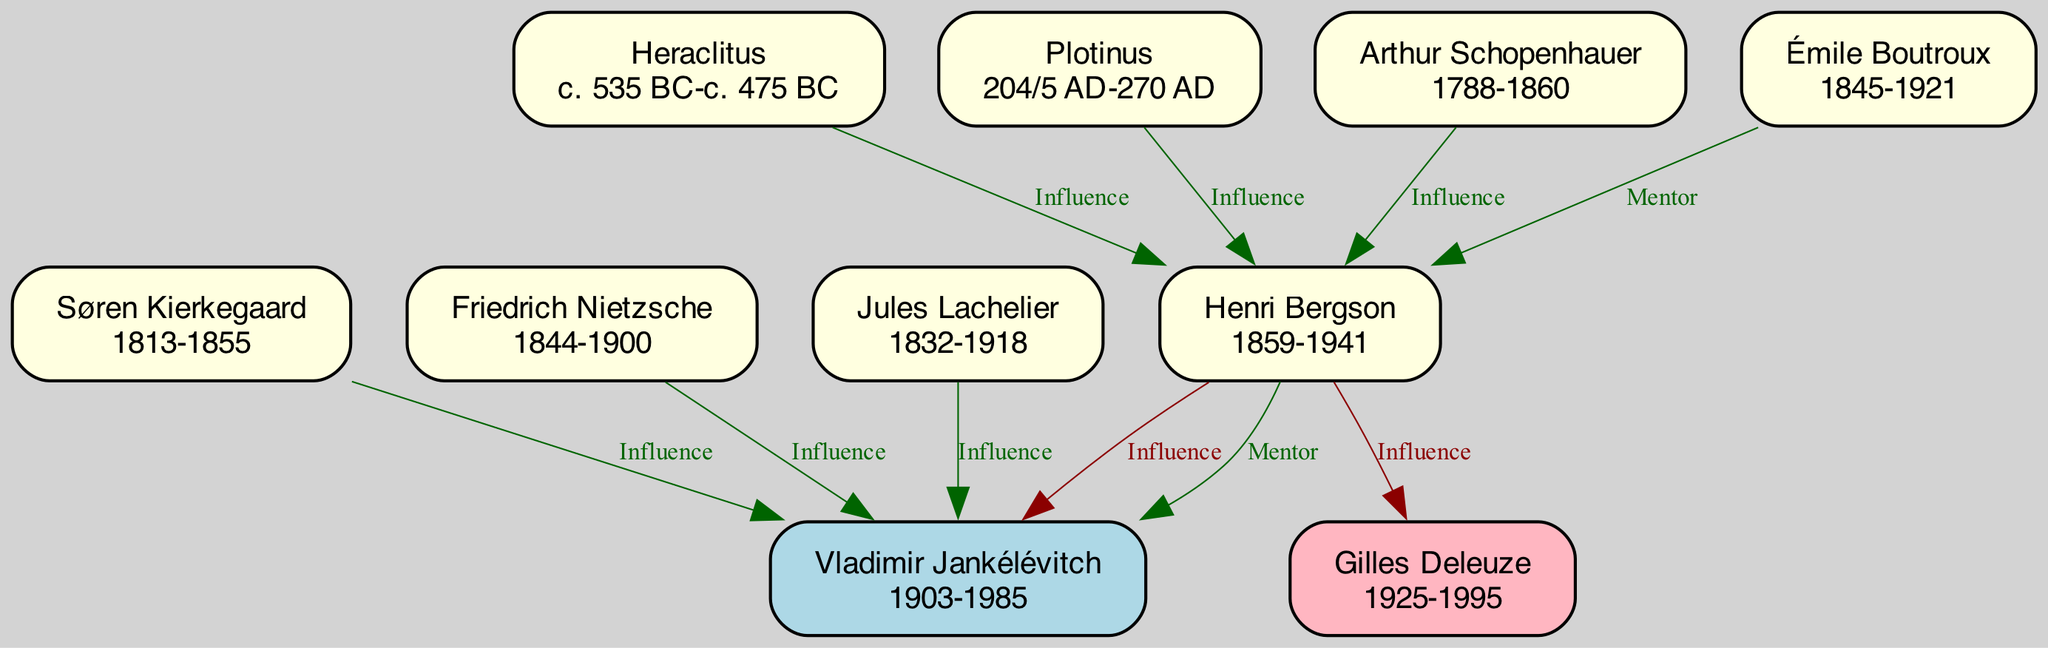What is the relationship between Henri Bergson and Vladimir Jankélévitch? The diagram shows that Henri Bergson is listed as an influence on Vladimir Jankélévitch, indicating a one-way relationship where Bergson directly impacted Jankélévitch's thought.
Answer: Influence How many philosophers influenced Henri Bergson? By counting the nodes connected to Bergson that show the 'influence' relationship, there are four listed influences: Heraclitus, Plotinus, Arthur Schopenhauer, and Émile Boutroux.
Answer: 4 Who was the mentor of Vladimir Jankélévitch? The diagram indicates that Henri Bergson served as a mentor to Vladimir Jankélévitch, highlighting the personal interaction and influence Jankélévitch received from Bergson.
Answer: Henri Bergson What are the birth years of the philosophers listed? The diagram provides birth years for each philosopher listed, such as Henri Bergson (1859), Vladimir Jankélévitch (1903), Heraclitus (c. 535 BC), and others. The focus here can be on any specific philosopher asked about.
Answer: 1859, 1903, c. 535 BC (varies depending on philosopher) Which philosopher influenced both Henri Bergson and Vladimir Jankélévitch? When examining the diagram, it is evident that Henri Bergson is shown to influence Vladimir Jankélévitch, with no other philosopher directly influencing both. Therefore, Bergson uniquely connects these two thinkers.
Answer: Henri Bergson Which philosopher is noted for influence through metaphysical and spiritual dimensions? According to the diagram, Plotinus is specifically mentioned as having an influence on Henri Bergson through metaphysical and spiritual ideas, demonstrating his significance in Bergson's thought.
Answer: Plotinus How many nodes representing philosophers are in the diagram? By counting all the distinct philosophers represented, including those who influenced and were influenced, a total of eight individual philosophers can be identified within the diagram structure.
Answer: 8 Which philosopher is associated with existentialism in relation to Vladimir Jankélévitch? The diagram indicates that Søren Kierkegaard, who had a significant focus on existentialism, is listed as an influence on Vladimir Jankélévitch, tying his ideas directly to Jankélévitch's development.
Answer: Søren Kierkegaard What aspect of philosophy did Jankélévitch influence in Gilles Deleuze? The diagram states that Jankélévitch had an influence on Gilles Deleuze in the areas of metaphysics and the philosophy of difference, indicating how Jankélévitch's thoughts shaped Deleuze's work.
Answer: Metaphysics and philosophy of difference 